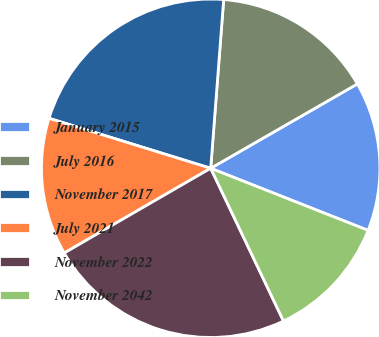Convert chart. <chart><loc_0><loc_0><loc_500><loc_500><pie_chart><fcel>January 2015<fcel>July 2016<fcel>November 2017<fcel>July 2021<fcel>November 2022<fcel>November 2042<nl><fcel>14.29%<fcel>15.47%<fcel>21.45%<fcel>13.12%<fcel>23.73%<fcel>11.94%<nl></chart> 